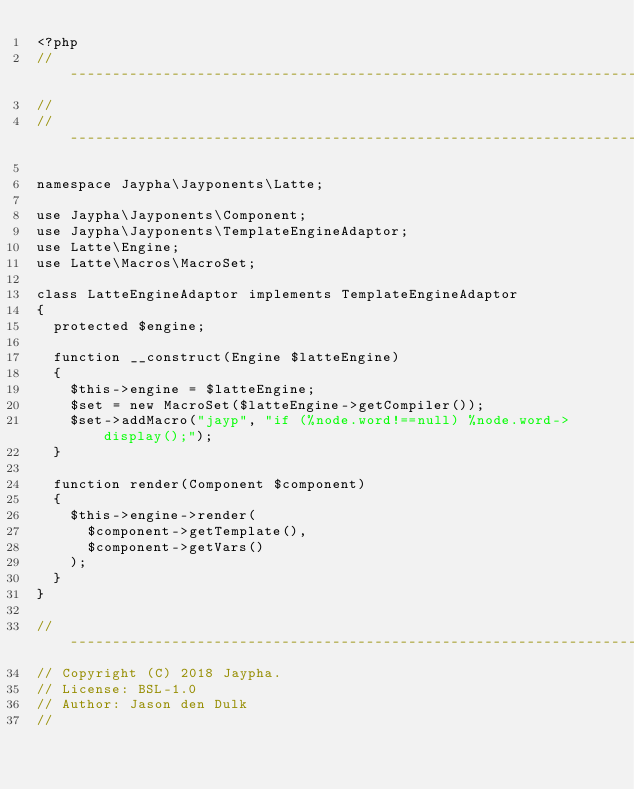<code> <loc_0><loc_0><loc_500><loc_500><_PHP_><?php
//----------------------------------------------------------------------------
//
//----------------------------------------------------------------------------

namespace Jaypha\Jayponents\Latte;

use Jaypha\Jayponents\Component;
use Jaypha\Jayponents\TemplateEngineAdaptor;
use Latte\Engine;
use Latte\Macros\MacroSet;

class LatteEngineAdaptor implements TemplateEngineAdaptor
{
  protected $engine;

  function __construct(Engine $latteEngine)
  {
    $this->engine = $latteEngine;
    $set = new MacroSet($latteEngine->getCompiler());
    $set->addMacro("jayp", "if (%node.word!==null) %node.word->display();");
  }

  function render(Component $component)
  {
    $this->engine->render(
      $component->getTemplate(),
      $component->getVars()
    );
  }
}

//----------------------------------------------------------------------------
// Copyright (C) 2018 Jaypha.
// License: BSL-1.0
// Author: Jason den Dulk
//
</code> 